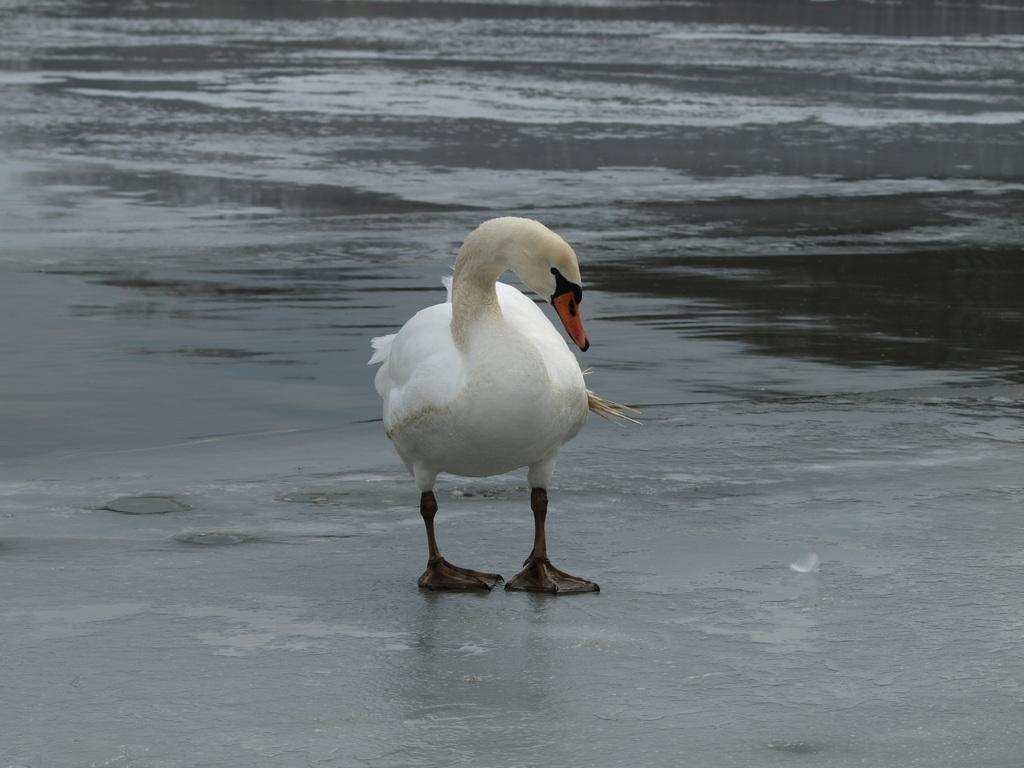What animal is present in the picture? There is a swan in the picture. What can be seen in the background of the picture? There is water visible in the background of the picture. What type of root can be seen growing near the swan in the picture? There is no root visible in the picture; it features a swan in a watery environment. 